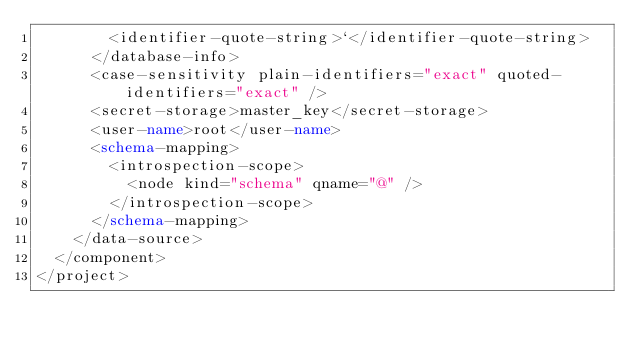Convert code to text. <code><loc_0><loc_0><loc_500><loc_500><_XML_>        <identifier-quote-string>`</identifier-quote-string>
      </database-info>
      <case-sensitivity plain-identifiers="exact" quoted-identifiers="exact" />
      <secret-storage>master_key</secret-storage>
      <user-name>root</user-name>
      <schema-mapping>
        <introspection-scope>
          <node kind="schema" qname="@" />
        </introspection-scope>
      </schema-mapping>
    </data-source>
  </component>
</project></code> 